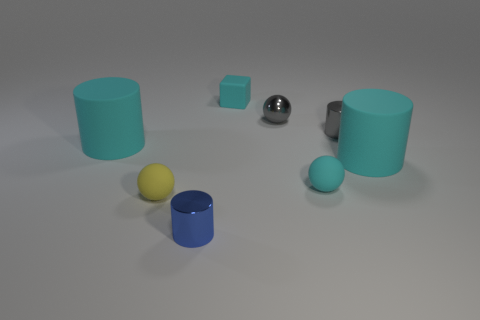Subtract 1 cylinders. How many cylinders are left? 3 Add 2 yellow balls. How many objects exist? 10 Subtract all balls. How many objects are left? 5 Add 1 metal things. How many metal things exist? 4 Subtract 0 blue blocks. How many objects are left? 8 Subtract all large blocks. Subtract all metal cylinders. How many objects are left? 6 Add 2 large objects. How many large objects are left? 4 